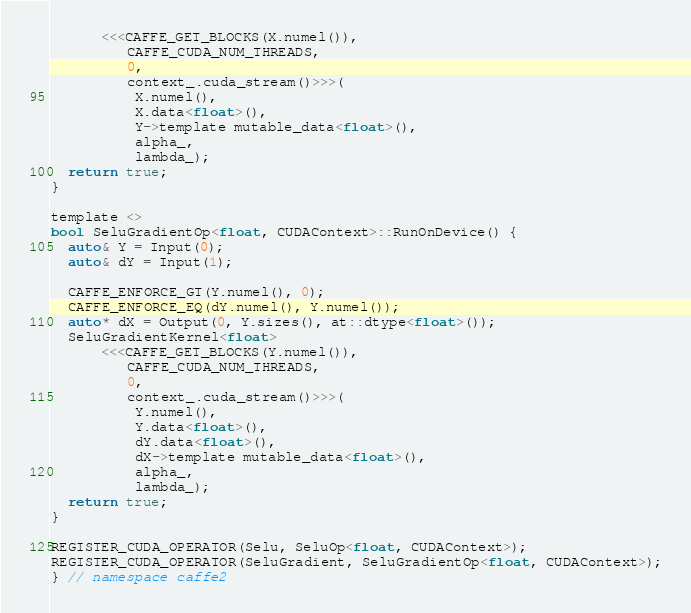Convert code to text. <code><loc_0><loc_0><loc_500><loc_500><_Cuda_>      <<<CAFFE_GET_BLOCKS(X.numel()),
         CAFFE_CUDA_NUM_THREADS,
         0,
         context_.cuda_stream()>>>(
          X.numel(),
          X.data<float>(),
          Y->template mutable_data<float>(),
          alpha_,
          lambda_);
  return true;
}

template <>
bool SeluGradientOp<float, CUDAContext>::RunOnDevice() {
  auto& Y = Input(0);
  auto& dY = Input(1);

  CAFFE_ENFORCE_GT(Y.numel(), 0);
  CAFFE_ENFORCE_EQ(dY.numel(), Y.numel());
  auto* dX = Output(0, Y.sizes(), at::dtype<float>());
  SeluGradientKernel<float>
      <<<CAFFE_GET_BLOCKS(Y.numel()),
         CAFFE_CUDA_NUM_THREADS,
         0,
         context_.cuda_stream()>>>(
          Y.numel(),
          Y.data<float>(),
          dY.data<float>(),
          dX->template mutable_data<float>(),
          alpha_,
          lambda_);
  return true;
}

REGISTER_CUDA_OPERATOR(Selu, SeluOp<float, CUDAContext>);
REGISTER_CUDA_OPERATOR(SeluGradient, SeluGradientOp<float, CUDAContext>);
} // namespace caffe2
</code> 